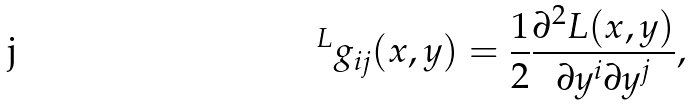<formula> <loc_0><loc_0><loc_500><loc_500>\ ^ { L } g _ { i j } ( x , y ) = \frac { 1 } { 2 } \frac { \partial ^ { 2 } L ( x , y ) } { \partial y ^ { i } \partial y ^ { j } } ,</formula> 